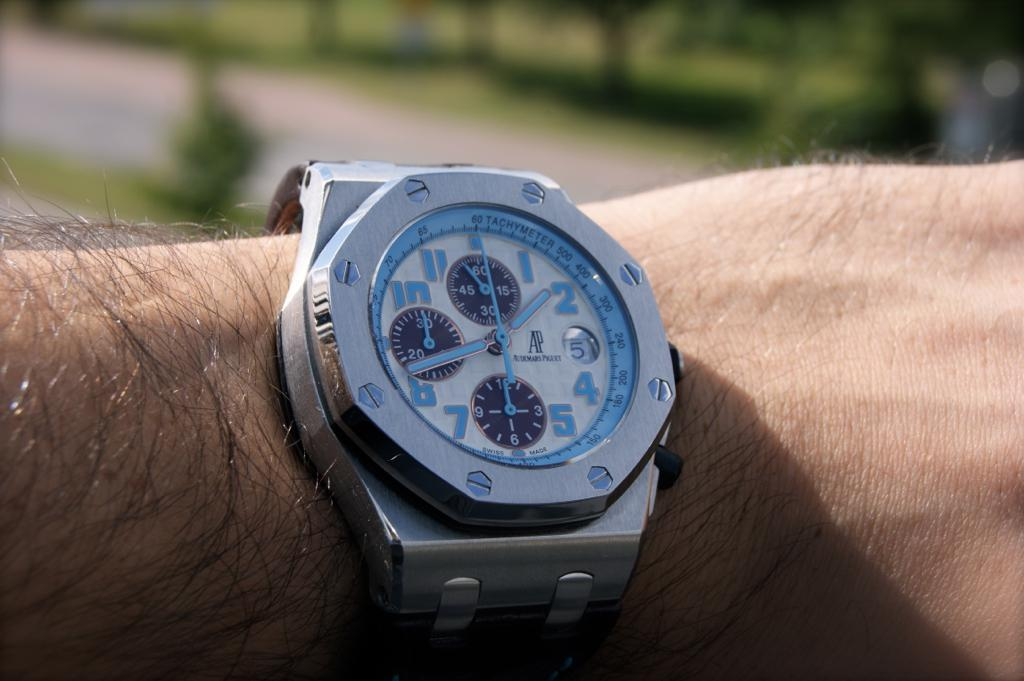<image>
Create a compact narrative representing the image presented. A man has an AP watch on his wrist showing the time of 1:42. 